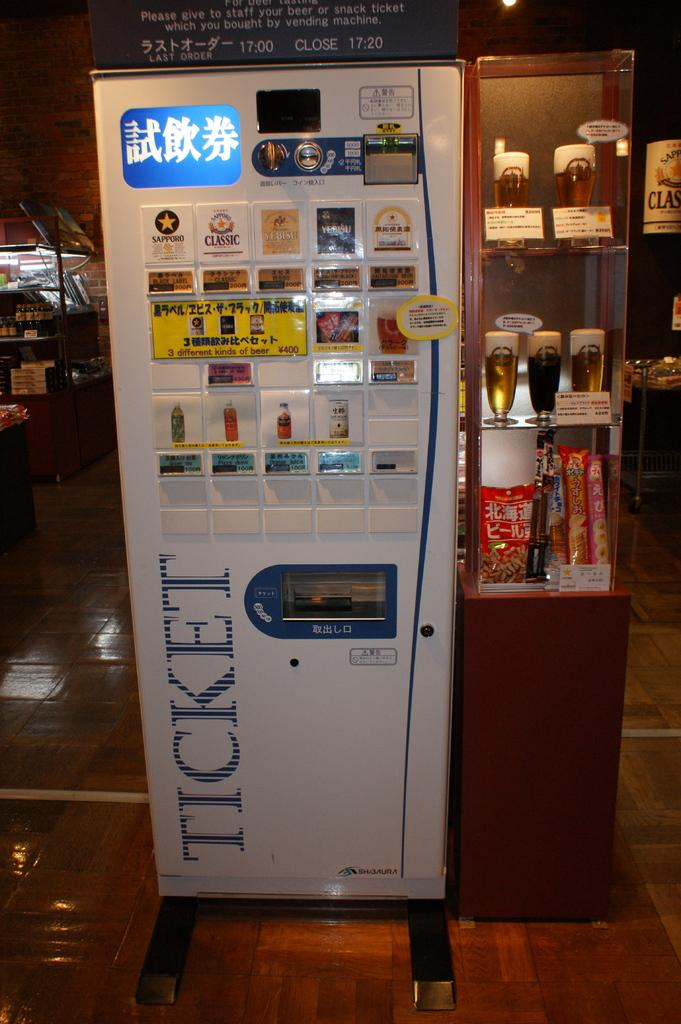<image>
Relay a brief, clear account of the picture shown. A Ticket vending machine is selling drinks, including three different kinds of beer. 